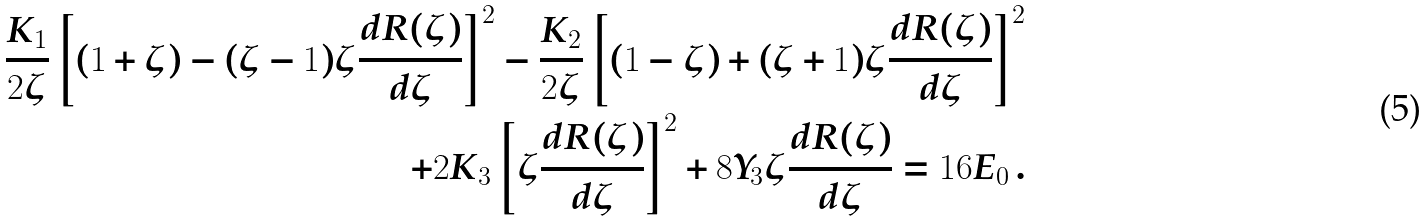Convert formula to latex. <formula><loc_0><loc_0><loc_500><loc_500>\frac { K _ { 1 } } { 2 \zeta } \left [ ( 1 + \zeta ) - ( \zeta - 1 ) \zeta \frac { d R ( \zeta ) } { d \zeta } \right ] ^ { 2 } - \frac { K _ { 2 } } { 2 \zeta } \left [ ( 1 - \zeta ) + ( \zeta + 1 ) \zeta \frac { d R ( \zeta ) } { d \zeta } \right ] ^ { 2 } \\ + 2 K _ { 3 } \left [ \zeta \frac { d R ( \zeta ) } { d \zeta } \right ] ^ { 2 } + 8 Y _ { 3 } \zeta \frac { d R ( \zeta ) } { d \zeta } = 1 6 E _ { 0 } \, .</formula> 